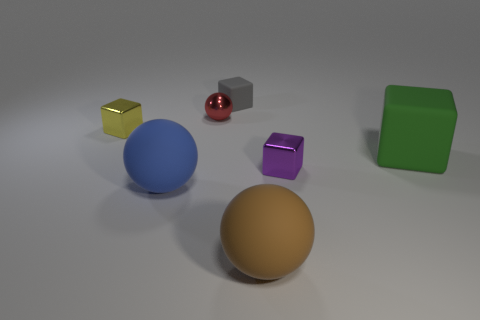Do the tiny rubber object and the large matte block have the same color? From the image provided, the tiny rubber object appears red and glossy, while the large matte block is green with a flat finish. Therefore, they do not share the same color nor finish. 